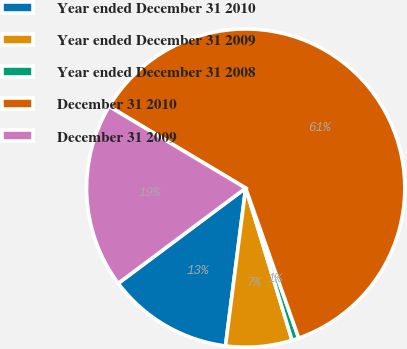Convert chart to OTSL. <chart><loc_0><loc_0><loc_500><loc_500><pie_chart><fcel>Year ended December 31 2010<fcel>Year ended December 31 2009<fcel>Year ended December 31 2008<fcel>December 31 2010<fcel>December 31 2009<nl><fcel>12.76%<fcel>6.73%<fcel>0.7%<fcel>61.01%<fcel>18.79%<nl></chart> 